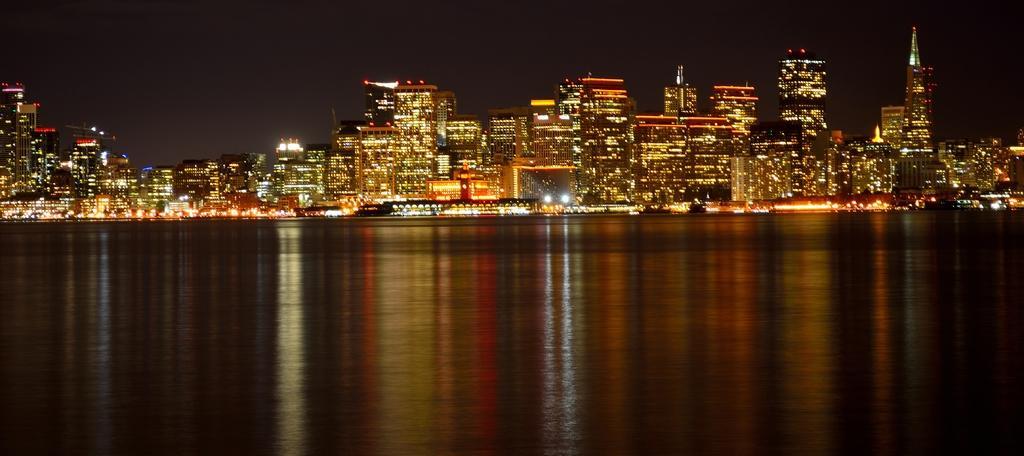In one or two sentences, can you explain what this image depicts? In this picture I can observe a river. In the background there are buildings and sky. 